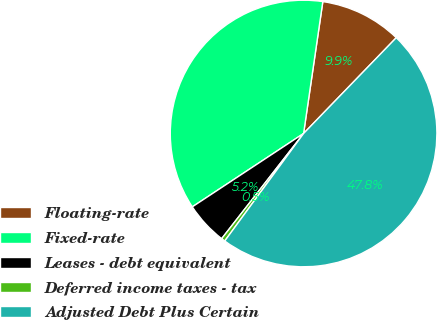Convert chart. <chart><loc_0><loc_0><loc_500><loc_500><pie_chart><fcel>Floating-rate<fcel>Fixed-rate<fcel>Leases - debt equivalent<fcel>Deferred income taxes - tax<fcel>Adjusted Debt Plus Certain<nl><fcel>9.93%<fcel>36.58%<fcel>5.19%<fcel>0.46%<fcel>47.83%<nl></chart> 